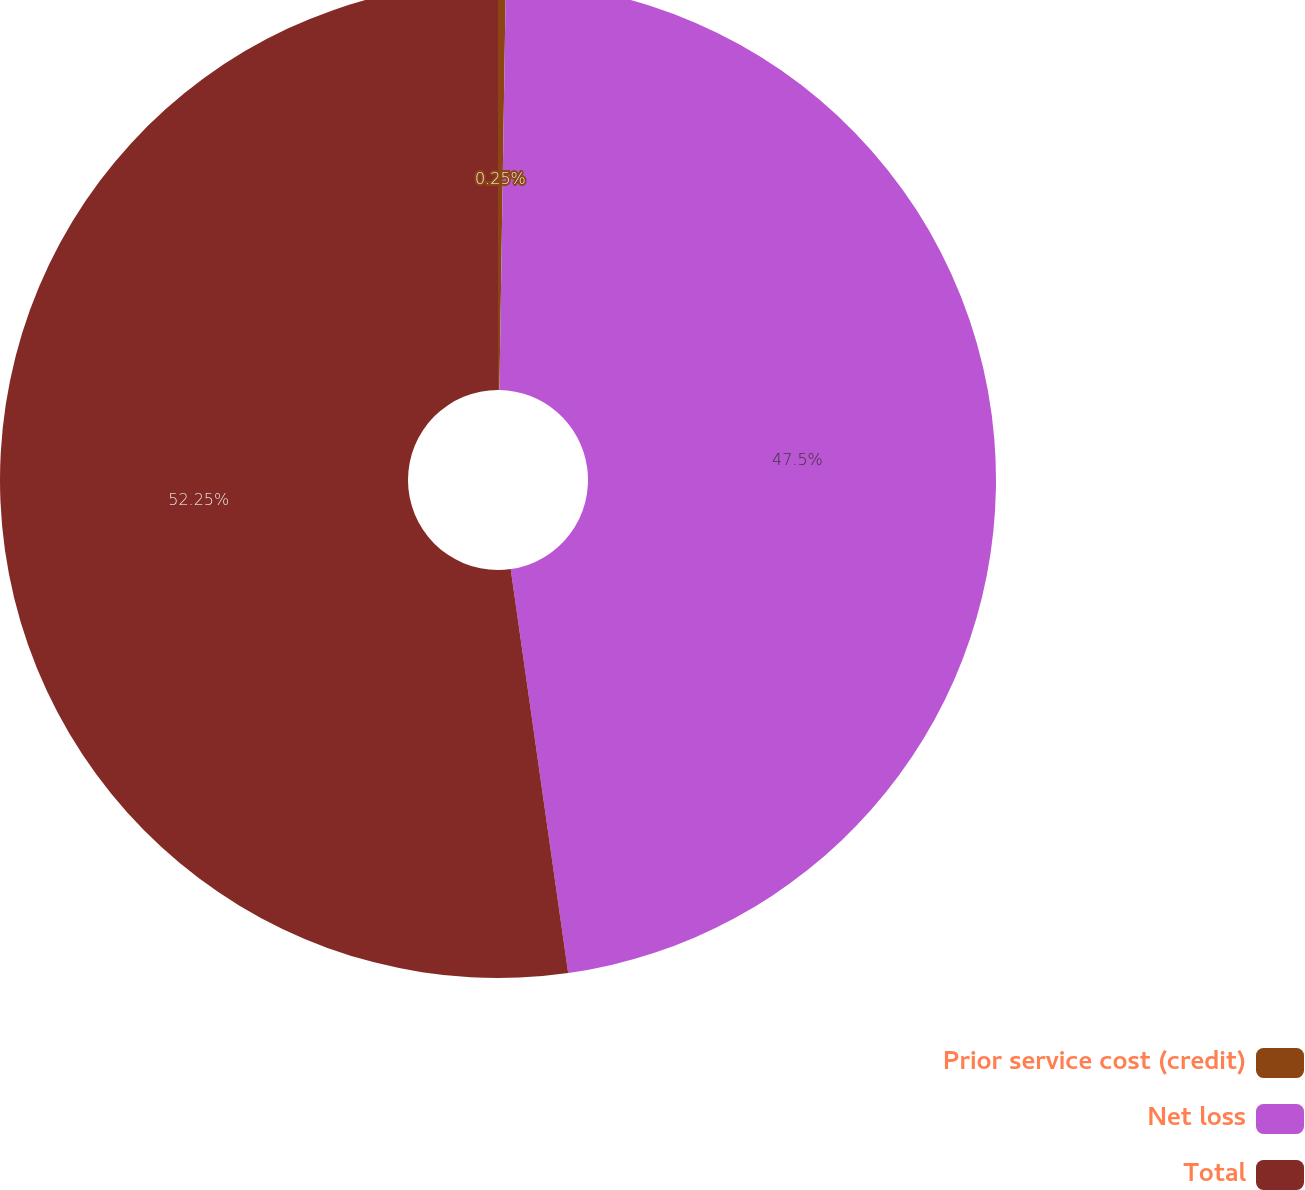Convert chart. <chart><loc_0><loc_0><loc_500><loc_500><pie_chart><fcel>Prior service cost (credit)<fcel>Net loss<fcel>Total<nl><fcel>0.25%<fcel>47.5%<fcel>52.25%<nl></chart> 